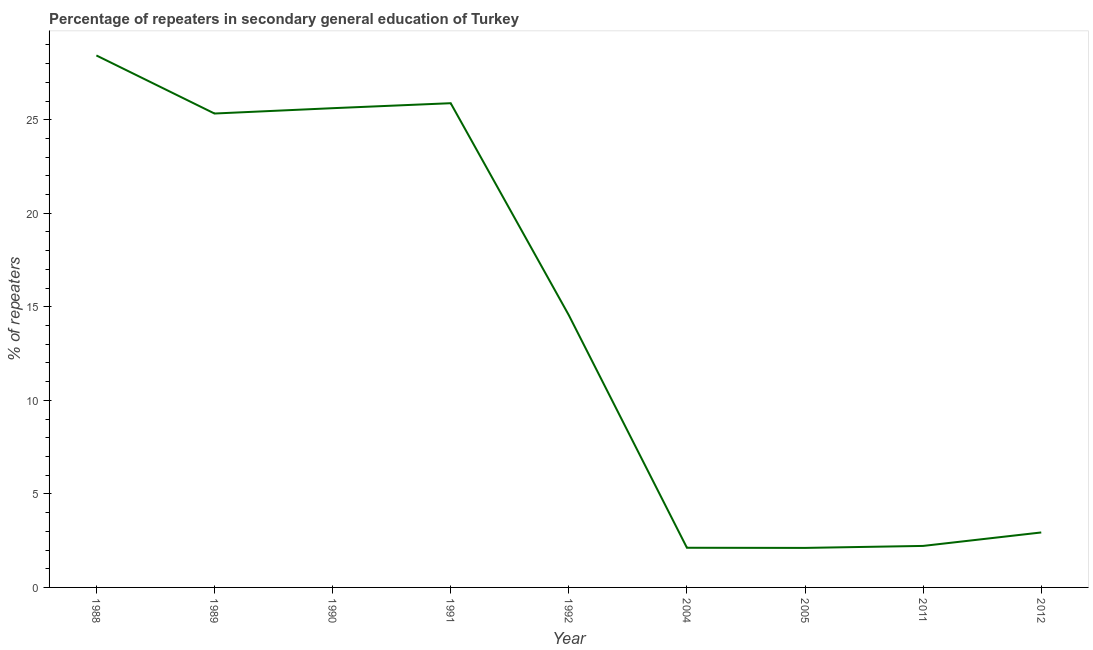What is the percentage of repeaters in 2011?
Ensure brevity in your answer.  2.22. Across all years, what is the maximum percentage of repeaters?
Provide a short and direct response. 28.44. Across all years, what is the minimum percentage of repeaters?
Offer a terse response. 2.11. In which year was the percentage of repeaters minimum?
Offer a very short reply. 2005. What is the sum of the percentage of repeaters?
Your answer should be very brief. 129.21. What is the difference between the percentage of repeaters in 1991 and 2005?
Ensure brevity in your answer.  23.77. What is the average percentage of repeaters per year?
Make the answer very short. 14.36. What is the median percentage of repeaters?
Offer a very short reply. 14.55. In how many years, is the percentage of repeaters greater than 5 %?
Offer a very short reply. 5. Do a majority of the years between 2004 and 2012 (inclusive) have percentage of repeaters greater than 17 %?
Make the answer very short. No. What is the ratio of the percentage of repeaters in 1989 to that in 1990?
Provide a succinct answer. 0.99. Is the percentage of repeaters in 1988 less than that in 2005?
Your response must be concise. No. Is the difference between the percentage of repeaters in 1990 and 2011 greater than the difference between any two years?
Give a very brief answer. No. What is the difference between the highest and the second highest percentage of repeaters?
Give a very brief answer. 2.55. What is the difference between the highest and the lowest percentage of repeaters?
Provide a succinct answer. 26.32. In how many years, is the percentage of repeaters greater than the average percentage of repeaters taken over all years?
Your response must be concise. 5. What is the difference between two consecutive major ticks on the Y-axis?
Your answer should be compact. 5. Are the values on the major ticks of Y-axis written in scientific E-notation?
Provide a succinct answer. No. Does the graph contain any zero values?
Your answer should be very brief. No. Does the graph contain grids?
Keep it short and to the point. No. What is the title of the graph?
Ensure brevity in your answer.  Percentage of repeaters in secondary general education of Turkey. What is the label or title of the X-axis?
Ensure brevity in your answer.  Year. What is the label or title of the Y-axis?
Provide a succinct answer. % of repeaters. What is the % of repeaters in 1988?
Provide a short and direct response. 28.44. What is the % of repeaters in 1989?
Make the answer very short. 25.33. What is the % of repeaters in 1990?
Provide a succinct answer. 25.62. What is the % of repeaters in 1991?
Keep it short and to the point. 25.88. What is the % of repeaters in 1992?
Provide a succinct answer. 14.55. What is the % of repeaters in 2004?
Keep it short and to the point. 2.12. What is the % of repeaters in 2005?
Offer a very short reply. 2.11. What is the % of repeaters in 2011?
Give a very brief answer. 2.22. What is the % of repeaters in 2012?
Make the answer very short. 2.94. What is the difference between the % of repeaters in 1988 and 1989?
Keep it short and to the point. 3.1. What is the difference between the % of repeaters in 1988 and 1990?
Provide a succinct answer. 2.82. What is the difference between the % of repeaters in 1988 and 1991?
Provide a short and direct response. 2.55. What is the difference between the % of repeaters in 1988 and 1992?
Keep it short and to the point. 13.88. What is the difference between the % of repeaters in 1988 and 2004?
Your answer should be compact. 26.32. What is the difference between the % of repeaters in 1988 and 2005?
Provide a short and direct response. 26.32. What is the difference between the % of repeaters in 1988 and 2011?
Your response must be concise. 26.22. What is the difference between the % of repeaters in 1988 and 2012?
Your response must be concise. 25.5. What is the difference between the % of repeaters in 1989 and 1990?
Your answer should be very brief. -0.28. What is the difference between the % of repeaters in 1989 and 1991?
Your answer should be very brief. -0.55. What is the difference between the % of repeaters in 1989 and 1992?
Keep it short and to the point. 10.78. What is the difference between the % of repeaters in 1989 and 2004?
Ensure brevity in your answer.  23.21. What is the difference between the % of repeaters in 1989 and 2005?
Your response must be concise. 23.22. What is the difference between the % of repeaters in 1989 and 2011?
Offer a terse response. 23.11. What is the difference between the % of repeaters in 1989 and 2012?
Offer a very short reply. 22.39. What is the difference between the % of repeaters in 1990 and 1991?
Your answer should be compact. -0.27. What is the difference between the % of repeaters in 1990 and 1992?
Provide a succinct answer. 11.06. What is the difference between the % of repeaters in 1990 and 2004?
Your answer should be very brief. 23.5. What is the difference between the % of repeaters in 1990 and 2005?
Your response must be concise. 23.5. What is the difference between the % of repeaters in 1990 and 2011?
Provide a short and direct response. 23.4. What is the difference between the % of repeaters in 1990 and 2012?
Your response must be concise. 22.68. What is the difference between the % of repeaters in 1991 and 1992?
Provide a short and direct response. 11.33. What is the difference between the % of repeaters in 1991 and 2004?
Keep it short and to the point. 23.76. What is the difference between the % of repeaters in 1991 and 2005?
Keep it short and to the point. 23.77. What is the difference between the % of repeaters in 1991 and 2011?
Your answer should be compact. 23.66. What is the difference between the % of repeaters in 1991 and 2012?
Your answer should be very brief. 22.94. What is the difference between the % of repeaters in 1992 and 2004?
Provide a succinct answer. 12.43. What is the difference between the % of repeaters in 1992 and 2005?
Make the answer very short. 12.44. What is the difference between the % of repeaters in 1992 and 2011?
Your response must be concise. 12.33. What is the difference between the % of repeaters in 1992 and 2012?
Keep it short and to the point. 11.61. What is the difference between the % of repeaters in 2004 and 2005?
Keep it short and to the point. 0.01. What is the difference between the % of repeaters in 2004 and 2011?
Offer a terse response. -0.1. What is the difference between the % of repeaters in 2004 and 2012?
Your response must be concise. -0.82. What is the difference between the % of repeaters in 2005 and 2011?
Your answer should be compact. -0.11. What is the difference between the % of repeaters in 2005 and 2012?
Keep it short and to the point. -0.83. What is the difference between the % of repeaters in 2011 and 2012?
Offer a very short reply. -0.72. What is the ratio of the % of repeaters in 1988 to that in 1989?
Provide a succinct answer. 1.12. What is the ratio of the % of repeaters in 1988 to that in 1990?
Make the answer very short. 1.11. What is the ratio of the % of repeaters in 1988 to that in 1991?
Provide a succinct answer. 1.1. What is the ratio of the % of repeaters in 1988 to that in 1992?
Provide a short and direct response. 1.95. What is the ratio of the % of repeaters in 1988 to that in 2004?
Your response must be concise. 13.41. What is the ratio of the % of repeaters in 1988 to that in 2005?
Make the answer very short. 13.46. What is the ratio of the % of repeaters in 1988 to that in 2011?
Offer a terse response. 12.82. What is the ratio of the % of repeaters in 1988 to that in 2012?
Offer a very short reply. 9.68. What is the ratio of the % of repeaters in 1989 to that in 1990?
Provide a short and direct response. 0.99. What is the ratio of the % of repeaters in 1989 to that in 1991?
Provide a short and direct response. 0.98. What is the ratio of the % of repeaters in 1989 to that in 1992?
Make the answer very short. 1.74. What is the ratio of the % of repeaters in 1989 to that in 2004?
Your answer should be compact. 11.95. What is the ratio of the % of repeaters in 1989 to that in 2005?
Give a very brief answer. 11.99. What is the ratio of the % of repeaters in 1989 to that in 2011?
Ensure brevity in your answer.  11.42. What is the ratio of the % of repeaters in 1989 to that in 2012?
Offer a very short reply. 8.62. What is the ratio of the % of repeaters in 1990 to that in 1992?
Give a very brief answer. 1.76. What is the ratio of the % of repeaters in 1990 to that in 2004?
Make the answer very short. 12.08. What is the ratio of the % of repeaters in 1990 to that in 2005?
Offer a very short reply. 12.13. What is the ratio of the % of repeaters in 1990 to that in 2011?
Offer a very short reply. 11.54. What is the ratio of the % of repeaters in 1990 to that in 2012?
Provide a short and direct response. 8.72. What is the ratio of the % of repeaters in 1991 to that in 1992?
Your answer should be compact. 1.78. What is the ratio of the % of repeaters in 1991 to that in 2004?
Offer a terse response. 12.21. What is the ratio of the % of repeaters in 1991 to that in 2005?
Your response must be concise. 12.25. What is the ratio of the % of repeaters in 1991 to that in 2011?
Your response must be concise. 11.67. What is the ratio of the % of repeaters in 1991 to that in 2012?
Make the answer very short. 8.81. What is the ratio of the % of repeaters in 1992 to that in 2004?
Offer a very short reply. 6.87. What is the ratio of the % of repeaters in 1992 to that in 2005?
Offer a terse response. 6.89. What is the ratio of the % of repeaters in 1992 to that in 2011?
Provide a succinct answer. 6.56. What is the ratio of the % of repeaters in 1992 to that in 2012?
Give a very brief answer. 4.95. What is the ratio of the % of repeaters in 2004 to that in 2005?
Ensure brevity in your answer.  1. What is the ratio of the % of repeaters in 2004 to that in 2011?
Give a very brief answer. 0.95. What is the ratio of the % of repeaters in 2004 to that in 2012?
Provide a succinct answer. 0.72. What is the ratio of the % of repeaters in 2005 to that in 2011?
Your response must be concise. 0.95. What is the ratio of the % of repeaters in 2005 to that in 2012?
Keep it short and to the point. 0.72. What is the ratio of the % of repeaters in 2011 to that in 2012?
Your answer should be compact. 0.76. 